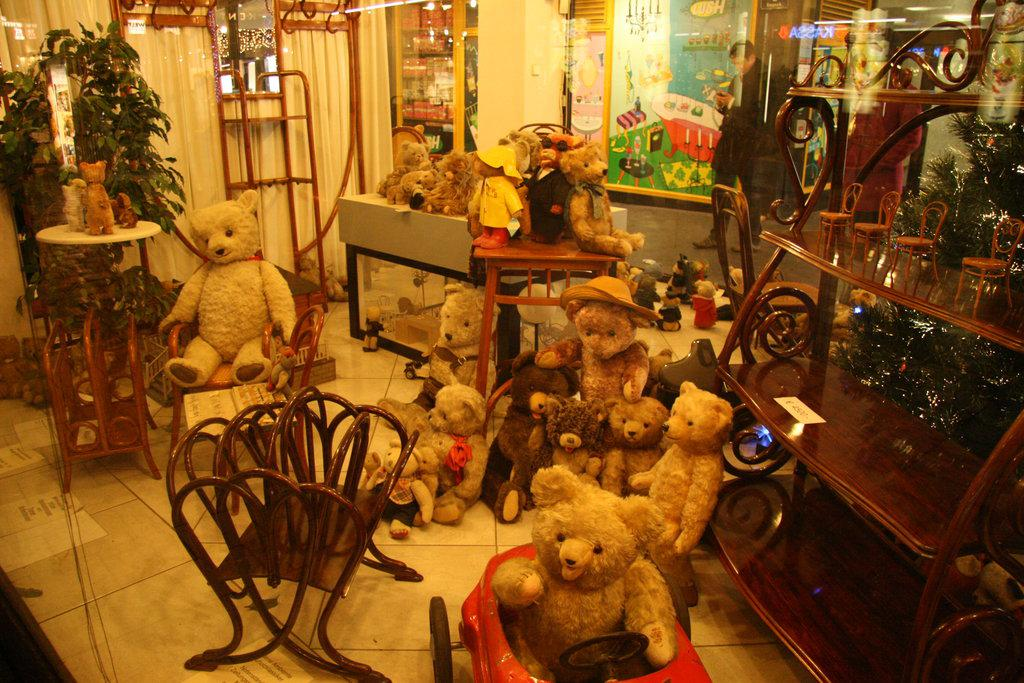Question: where is this picture taken?
Choices:
A. Antique shop.
B. At a wedding.
C. At the park.
D. In a warehouse.
Answer with the letter. Answer: A Question: what is behind the shelf?
Choices:
A. A christmas tree.
B. A little girl.
C. A puppy.
D. Money.
Answer with the letter. Answer: A Question: why is there a picture on the wall?
Choices:
A. To hide a crack.
B. Because it's a museum.
C. To decorate.
D. It's a memento of a trip to Paris.
Answer with the letter. Answer: C Question: what is on a stand in the background?
Choices:
A. A pot.
B. A man.
C. A plant.
D. A child.
Answer with the letter. Answer: C Question: what color are teddy bears?
Choices:
A. Red.
B. White and brown.
C. Purple.
D. Green.
Answer with the letter. Answer: B Question: what is there a set of?
Choices:
A. A set of knives.
B. A set of keys.
C. A set of shelves with doll-sized chairs on it.
D. A set of buttons.
Answer with the letter. Answer: C Question: what kind of shop is this?
Choices:
A. A smoke shop.
B. A candy shop.
C. A barber shop.
D. A shop that has many teddy bears in various places.
Answer with the letter. Answer: D Question: what is hanging on the wall?
Choices:
A. A poster.
B. A shelf.
C. An art print.
D. A picture.
Answer with the letter. Answer: D Question: what are tiny and are on the shelf?
Choices:
A. Books.
B. Cars.
C. Buttons.
D. Chairs.
Answer with the letter. Answer: D Question: what is the shelf made of?
Choices:
A. Brick.
B. Concrete.
C. Wood.
D. Cardboard.
Answer with the letter. Answer: C Question: where is the teddy bear sitting?
Choices:
A. On the shelf.
B. Beside the man.
C. On the bed.
D. In the car.
Answer with the letter. Answer: D Question: who checks mobile device?
Choices:
A. Girl with suitcase.
B. Man in background.
C. Woman in hat.
D. Boy on bench.
Answer with the letter. Answer: B Question: what is green?
Choices:
A. Grass.
B. Plant.
C. Tree.
D. Bench.
Answer with the letter. Answer: B Question: who rides toy car?
Choices:
A. Doll.
B. Hamster.
C. Action figure.
D. Teddy bear.
Answer with the letter. Answer: D 